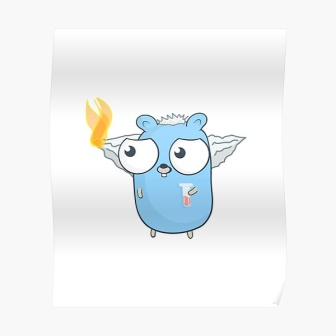What might be the environmental influence or habitat of this creature? The creature inhabits a fantastical forest known as the Whispering Woods. This environment is characterized by lush, bioluminescent flora where each plant emits a gentle glow at night, creating a serene and otherworldly ambiance. The air is perpetually filled with the soft hum of ancient magic, and the streams run with water imbued with healing properties. Tall, elegant trees with silver bark form a dense canopy overhead, providing a cool, shaded habitat perfect for the creature. The forest is also home to various other mystical beings, all coexisting harmoniously. Whispering Woods, the habitat of this creature, features a mesmerizing interplay of natural beauty and enchantment. During twilight, the bioluminescent plants illuminate the forest floor with a soft blue glow. Silver-barked trees arch gracefully, forming a natural cathedral under a canopy sprinkled with floating, luminescent spores. Streams of crystal-clear water, infused with healing properties, crisscross the landscape. This fantastical setting not only provides an ideal environment for the creature but also plays a crucial role in the delicate balance that sustains the forest's magical ecosystem. 